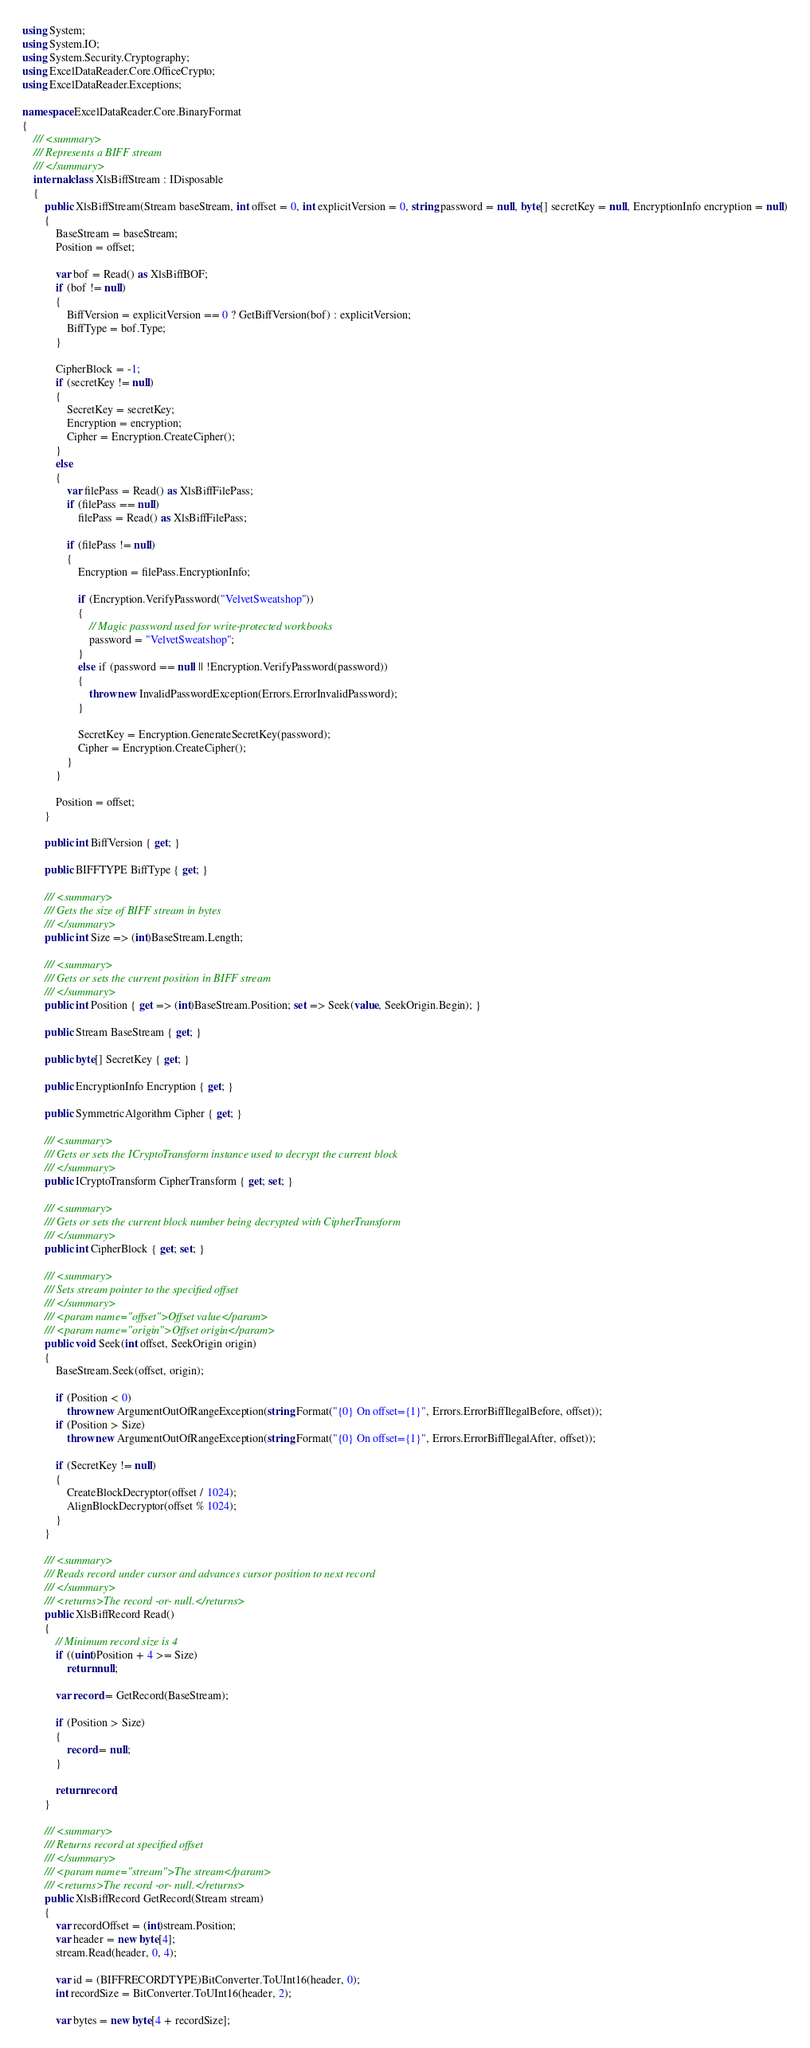Convert code to text. <code><loc_0><loc_0><loc_500><loc_500><_C#_>using System;
using System.IO;
using System.Security.Cryptography;
using ExcelDataReader.Core.OfficeCrypto;
using ExcelDataReader.Exceptions;

namespace ExcelDataReader.Core.BinaryFormat
{
    /// <summary>
    /// Represents a BIFF stream
    /// </summary>
    internal class XlsBiffStream : IDisposable
    {
        public XlsBiffStream(Stream baseStream, int offset = 0, int explicitVersion = 0, string password = null, byte[] secretKey = null, EncryptionInfo encryption = null)
        {
            BaseStream = baseStream;
            Position = offset;

            var bof = Read() as XlsBiffBOF;
            if (bof != null)
            { 
                BiffVersion = explicitVersion == 0 ? GetBiffVersion(bof) : explicitVersion;
                BiffType = bof.Type;
            }

            CipherBlock = -1;
            if (secretKey != null)
            {
                SecretKey = secretKey;
                Encryption = encryption;
                Cipher = Encryption.CreateCipher();
            }
            else
            {
                var filePass = Read() as XlsBiffFilePass;
                if (filePass == null)
                    filePass = Read() as XlsBiffFilePass;

                if (filePass != null)
                {
                    Encryption = filePass.EncryptionInfo;

                    if (Encryption.VerifyPassword("VelvetSweatshop"))
                    {
                        // Magic password used for write-protected workbooks
                        password = "VelvetSweatshop";
                    }
                    else if (password == null || !Encryption.VerifyPassword(password))
                    {
                        throw new InvalidPasswordException(Errors.ErrorInvalidPassword);
                    }

                    SecretKey = Encryption.GenerateSecretKey(password);
                    Cipher = Encryption.CreateCipher();
                }
            }

            Position = offset;
        }

        public int BiffVersion { get; }

        public BIFFTYPE BiffType { get; }

        /// <summary>
        /// Gets the size of BIFF stream in bytes
        /// </summary>
        public int Size => (int)BaseStream.Length;

        /// <summary>
        /// Gets or sets the current position in BIFF stream
        /// </summary>
        public int Position { get => (int)BaseStream.Position; set => Seek(value, SeekOrigin.Begin); }

        public Stream BaseStream { get; }

        public byte[] SecretKey { get; }

        public EncryptionInfo Encryption { get; }

        public SymmetricAlgorithm Cipher { get; }

        /// <summary>
        /// Gets or sets the ICryptoTransform instance used to decrypt the current block
        /// </summary>
        public ICryptoTransform CipherTransform { get; set; }

        /// <summary>
        /// Gets or sets the current block number being decrypted with CipherTransform
        /// </summary>
        public int CipherBlock { get; set; }

        /// <summary>
        /// Sets stream pointer to the specified offset
        /// </summary>
        /// <param name="offset">Offset value</param>
        /// <param name="origin">Offset origin</param>
        public void Seek(int offset, SeekOrigin origin)
        {
            BaseStream.Seek(offset, origin);

            if (Position < 0)
                throw new ArgumentOutOfRangeException(string.Format("{0} On offset={1}", Errors.ErrorBiffIlegalBefore, offset));
            if (Position > Size)
                throw new ArgumentOutOfRangeException(string.Format("{0} On offset={1}", Errors.ErrorBiffIlegalAfter, offset));

            if (SecretKey != null)
            { 
                CreateBlockDecryptor(offset / 1024);
                AlignBlockDecryptor(offset % 1024);
            }
        }

        /// <summary>
        /// Reads record under cursor and advances cursor position to next record
        /// </summary>
        /// <returns>The record -or- null.</returns>
        public XlsBiffRecord Read()
        {
            // Minimum record size is 4
            if ((uint)Position + 4 >= Size)
                return null;

            var record = GetRecord(BaseStream);

            if (Position > Size)
            {
                record = null;
            }

            return record;
        }

        /// <summary>
        /// Returns record at specified offset
        /// </summary>
        /// <param name="stream">The stream</param>
        /// <returns>The record -or- null.</returns>
        public XlsBiffRecord GetRecord(Stream stream)
        {
            var recordOffset = (int)stream.Position;
            var header = new byte[4];
            stream.Read(header, 0, 4);

            var id = (BIFFRECORDTYPE)BitConverter.ToUInt16(header, 0);
            int recordSize = BitConverter.ToUInt16(header, 2);

            var bytes = new byte[4 + recordSize];</code> 